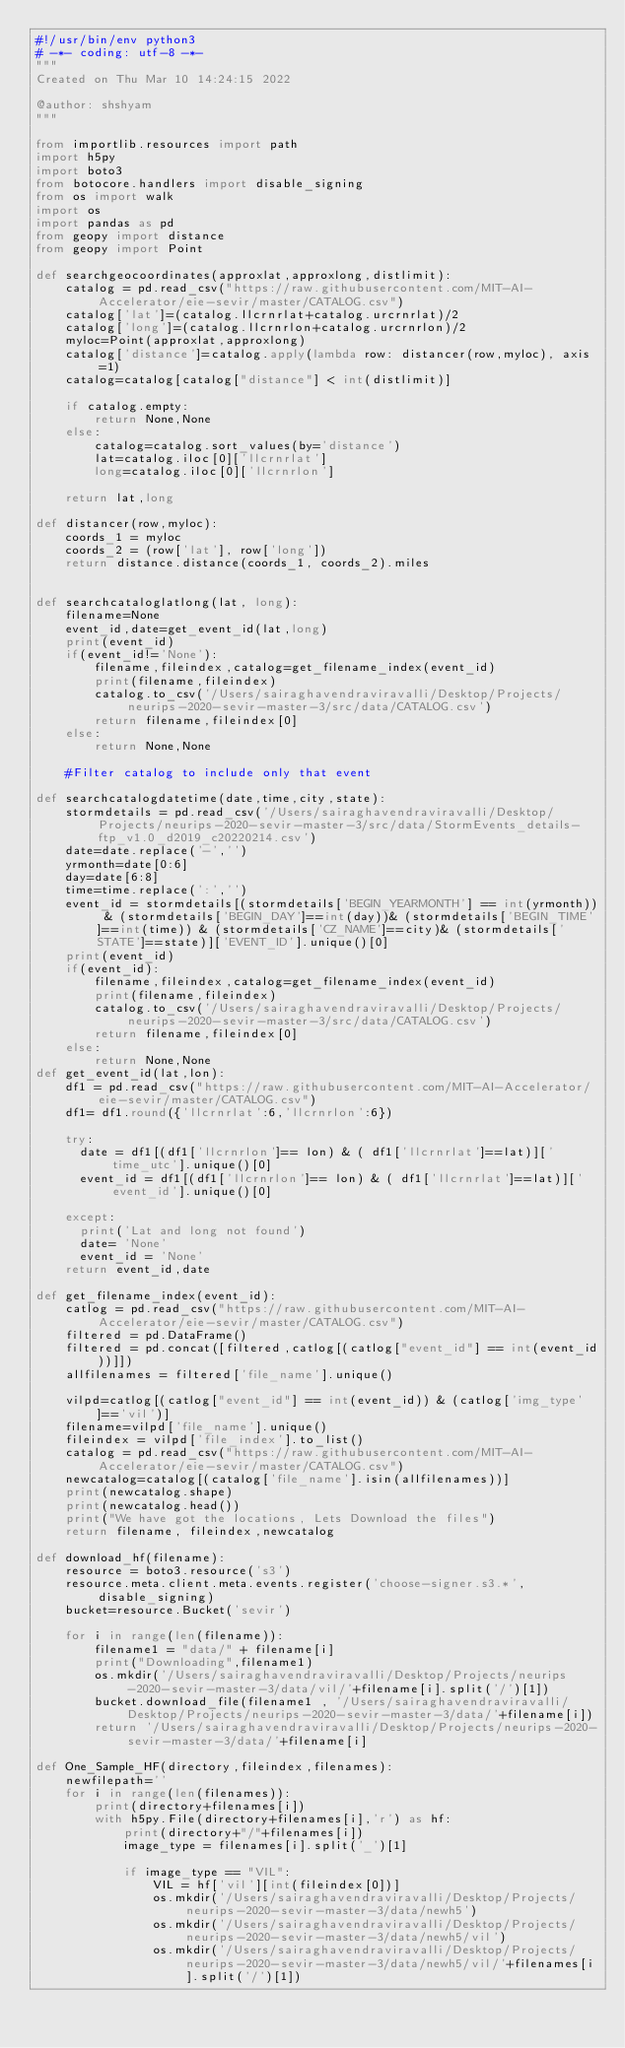Convert code to text. <code><loc_0><loc_0><loc_500><loc_500><_Python_>#!/usr/bin/env python3
# -*- coding: utf-8 -*-
"""
Created on Thu Mar 10 14:24:15 2022

@author: shshyam
"""

from importlib.resources import path
import h5py
import boto3
from botocore.handlers import disable_signing
from os import walk
import os
import pandas as pd
from geopy import distance
from geopy import Point

def searchgeocoordinates(approxlat,approxlong,distlimit):
    catalog = pd.read_csv("https://raw.githubusercontent.com/MIT-AI-Accelerator/eie-sevir/master/CATALOG.csv")
    catalog['lat']=(catalog.llcrnrlat+catalog.urcrnrlat)/2
    catalog['long']=(catalog.llcrnrlon+catalog.urcrnrlon)/2
    myloc=Point(approxlat,approxlong)
    catalog['distance']=catalog.apply(lambda row: distancer(row,myloc), axis=1)
    catalog=catalog[catalog["distance"] < int(distlimit)]

    if catalog.empty:
        return None,None
    else:
        catalog=catalog.sort_values(by='distance')
        lat=catalog.iloc[0]['llcrnrlat']
        long=catalog.iloc[0]['llcrnrlon']
    
    return lat,long

def distancer(row,myloc):
    coords_1 = myloc
    coords_2 = (row['lat'], row['long'])
    return distance.distance(coords_1, coords_2).miles


def searchcataloglatlong(lat, long):
    filename=None
    event_id,date=get_event_id(lat,long)
    print(event_id)
    if(event_id!='None'):
        filename,fileindex,catalog=get_filename_index(event_id)       
        print(filename,fileindex)
        catalog.to_csv('/Users/sairaghavendraviravalli/Desktop/Projects/neurips-2020-sevir-master-3/src/data/CATALOG.csv')
        return filename,fileindex[0]
    else:
        return None,None
    
    #Filter catalog to include only that event
    
def searchcatalogdatetime(date,time,city,state):
    stormdetails = pd.read_csv('/Users/sairaghavendraviravalli/Desktop/Projects/neurips-2020-sevir-master-3/src/data/StormEvents_details-ftp_v1.0_d2019_c20220214.csv')
    date=date.replace('-','')
    yrmonth=date[0:6]
    day=date[6:8]
    time=time.replace(':','')
    event_id = stormdetails[(stormdetails['BEGIN_YEARMONTH'] == int(yrmonth)) & (stormdetails['BEGIN_DAY']==int(day))& (stormdetails['BEGIN_TIME']==int(time)) & (stormdetails['CZ_NAME']==city)& (stormdetails['STATE']==state)]['EVENT_ID'].unique()[0]  
    print(event_id)
    if(event_id):
        filename,fileindex,catalog=get_filename_index(event_id)      
        print(filename,fileindex)
        catalog.to_csv('/Users/sairaghavendraviravalli/Desktop/Projects/neurips-2020-sevir-master-3/src/data/CATALOG.csv')
        return filename,fileindex[0]
    else:
        return None,None
def get_event_id(lat,lon):
    df1 = pd.read_csv("https://raw.githubusercontent.com/MIT-AI-Accelerator/eie-sevir/master/CATALOG.csv")
    df1= df1.round({'llcrnrlat':6,'llcrnrlon':6})
    
    try:
      date = df1[(df1['llcrnrlon']== lon) & ( df1['llcrnrlat']==lat)]['time_utc'].unique()[0]
      event_id = df1[(df1['llcrnrlon']== lon) & ( df1['llcrnrlat']==lat)]['event_id'].unique()[0]
    
    except:
      print('Lat and long not found')
      date= 'None'
      event_id = 'None'
    return event_id,date

def get_filename_index(event_id):
    catlog = pd.read_csv("https://raw.githubusercontent.com/MIT-AI-Accelerator/eie-sevir/master/CATALOG.csv")
    filtered = pd.DataFrame()
    filtered = pd.concat([filtered,catlog[(catlog["event_id"] == int(event_id))]])
    allfilenames = filtered['file_name'].unique()
    
    vilpd=catlog[(catlog["event_id"] == int(event_id)) & (catlog['img_type']=='vil')]
    filename=vilpd['file_name'].unique()
    fileindex = vilpd['file_index'].to_list()
    catalog = pd.read_csv("https://raw.githubusercontent.com/MIT-AI-Accelerator/eie-sevir/master/CATALOG.csv")
    newcatalog=catalog[(catalog['file_name'].isin(allfilenames))]
    print(newcatalog.shape)
    print(newcatalog.head())
    print("We have got the locations, Lets Download the files")    
    return filename, fileindex,newcatalog
    
def download_hf(filename):
    resource = boto3.resource('s3')
    resource.meta.client.meta.events.register('choose-signer.s3.*', disable_signing)
    bucket=resource.Bucket('sevir')
    
    for i in range(len(filename)):
        filename1 = "data/" + filename[i]
        print("Downloading",filename1)    
        os.mkdir('/Users/sairaghavendraviravalli/Desktop/Projects/neurips-2020-sevir-master-3/data/vil/'+filename[i].split('/')[1])
        bucket.download_file(filename1 , '/Users/sairaghavendraviravalli/Desktop/Projects/neurips-2020-sevir-master-3/data/'+filename[i]) 
        return '/Users/sairaghavendraviravalli/Desktop/Projects/neurips-2020-sevir-master-3/data/'+filename[i]
    
def One_Sample_HF(directory,fileindex,filenames):
    newfilepath=''
    for i in range(len(filenames)):
        print(directory+filenames[i])
        with h5py.File(directory+filenames[i],'r') as hf:
            print(directory+"/"+filenames[i])
            image_type = filenames[i].split('_')[1]
            
            if image_type == "VIL":
                VIL = hf['vil'][int(fileindex[0])]
                os.mkdir('/Users/sairaghavendraviravalli/Desktop/Projects/neurips-2020-sevir-master-3/data/newh5')
                os.mkdir('/Users/sairaghavendraviravalli/Desktop/Projects/neurips-2020-sevir-master-3/data/newh5/vil')
                os.mkdir('/Users/sairaghavendraviravalli/Desktop/Projects/neurips-2020-sevir-master-3/data/newh5/vil/'+filenames[i].split('/')[1])</code> 